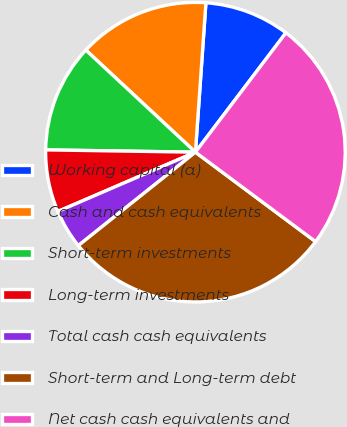<chart> <loc_0><loc_0><loc_500><loc_500><pie_chart><fcel>Working capital (a)<fcel>Cash and cash equivalents<fcel>Short-term investments<fcel>Long-term investments<fcel>Total cash cash equivalents<fcel>Short-term and Long-term debt<fcel>Net cash cash equivalents and<nl><fcel>9.21%<fcel>14.18%<fcel>11.69%<fcel>6.72%<fcel>4.24%<fcel>29.1%<fcel>24.86%<nl></chart> 